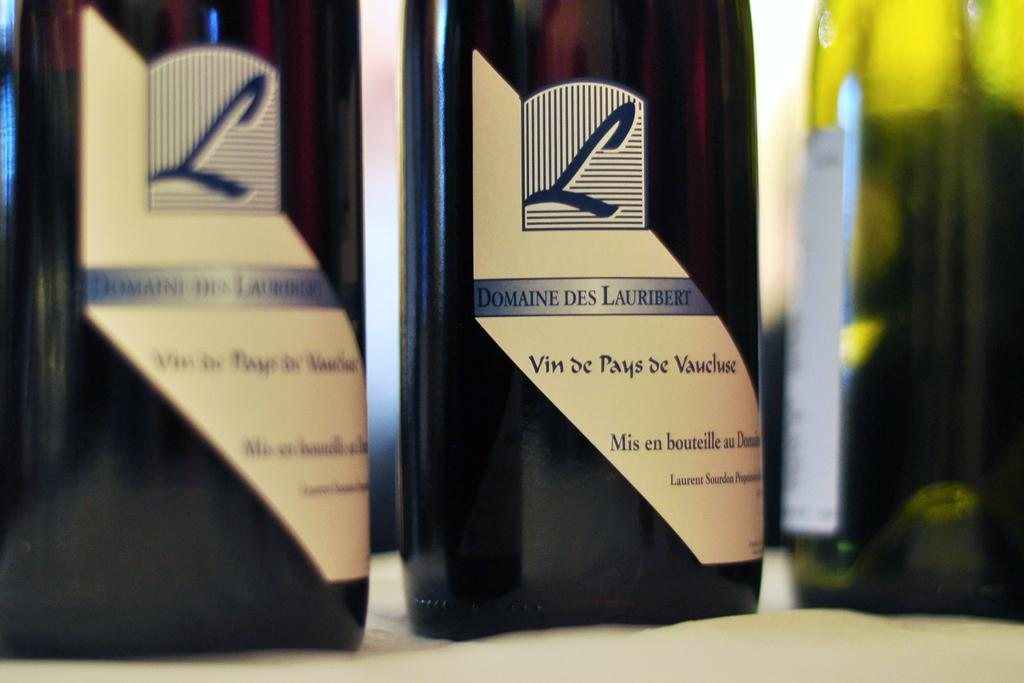<image>
Offer a succinct explanation of the picture presented. A bottle of Domaine des Lauribert sits with other wine bottles. 